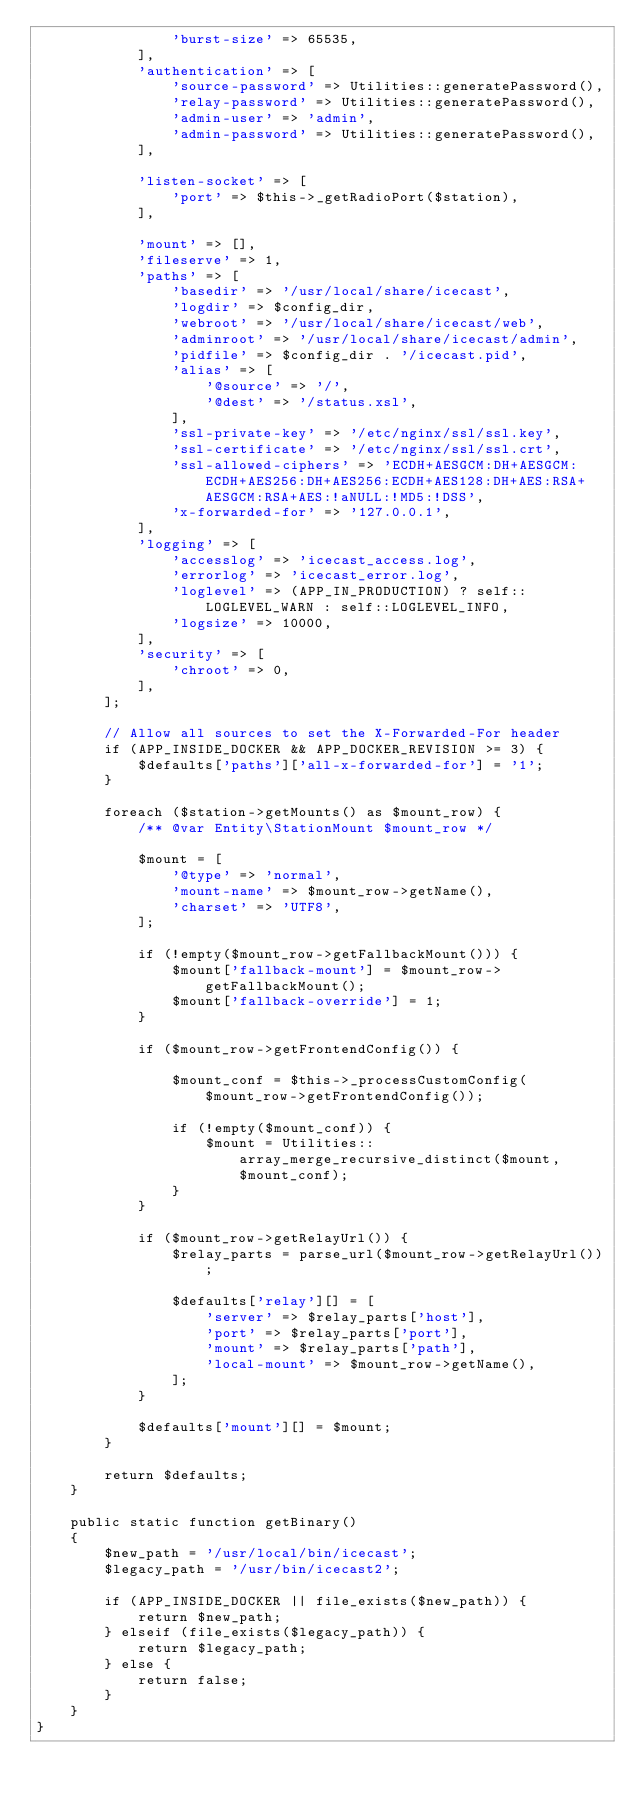<code> <loc_0><loc_0><loc_500><loc_500><_PHP_>                'burst-size' => 65535,
            ],
            'authentication' => [
                'source-password' => Utilities::generatePassword(),
                'relay-password' => Utilities::generatePassword(),
                'admin-user' => 'admin',
                'admin-password' => Utilities::generatePassword(),
            ],

            'listen-socket' => [
                'port' => $this->_getRadioPort($station),
            ],

            'mount' => [],
            'fileserve' => 1,
            'paths' => [
                'basedir' => '/usr/local/share/icecast',
                'logdir' => $config_dir,
                'webroot' => '/usr/local/share/icecast/web',
                'adminroot' => '/usr/local/share/icecast/admin',
                'pidfile' => $config_dir . '/icecast.pid',
                'alias' => [
                    '@source' => '/',
                    '@dest' => '/status.xsl',
                ],
                'ssl-private-key' => '/etc/nginx/ssl/ssl.key',
                'ssl-certificate' => '/etc/nginx/ssl/ssl.crt',
                'ssl-allowed-ciphers' => 'ECDH+AESGCM:DH+AESGCM:ECDH+AES256:DH+AES256:ECDH+AES128:DH+AES:RSA+AESGCM:RSA+AES:!aNULL:!MD5:!DSS',
                'x-forwarded-for' => '127.0.0.1',
            ],
            'logging' => [
                'accesslog' => 'icecast_access.log',
                'errorlog' => 'icecast_error.log',
                'loglevel' => (APP_IN_PRODUCTION) ? self::LOGLEVEL_WARN : self::LOGLEVEL_INFO,
                'logsize' => 10000,
            ],
            'security' => [
                'chroot' => 0,
            ],
        ];

        // Allow all sources to set the X-Forwarded-For header
        if (APP_INSIDE_DOCKER && APP_DOCKER_REVISION >= 3) {
            $defaults['paths']['all-x-forwarded-for'] = '1';
        }

        foreach ($station->getMounts() as $mount_row) {
            /** @var Entity\StationMount $mount_row */

            $mount = [
                '@type' => 'normal',
                'mount-name' => $mount_row->getName(),
                'charset' => 'UTF8',
            ];

            if (!empty($mount_row->getFallbackMount())) {
                $mount['fallback-mount'] = $mount_row->getFallbackMount();
                $mount['fallback-override'] = 1;
            }

            if ($mount_row->getFrontendConfig()) {

                $mount_conf = $this->_processCustomConfig($mount_row->getFrontendConfig());

                if (!empty($mount_conf)) {
                    $mount = Utilities::array_merge_recursive_distinct($mount, $mount_conf);
                }
            }

            if ($mount_row->getRelayUrl()) {
                $relay_parts = parse_url($mount_row->getRelayUrl());

                $defaults['relay'][] = [
                    'server' => $relay_parts['host'],
                    'port' => $relay_parts['port'],
                    'mount' => $relay_parts['path'],
                    'local-mount' => $mount_row->getName(),
                ];
            }

            $defaults['mount'][] = $mount;
        }

        return $defaults;
    }

    public static function getBinary()
    {
        $new_path = '/usr/local/bin/icecast';
        $legacy_path = '/usr/bin/icecast2';

        if (APP_INSIDE_DOCKER || file_exists($new_path)) {
            return $new_path;
        } elseif (file_exists($legacy_path)) {
            return $legacy_path;
        } else {
            return false;
        }
    }
}
</code> 